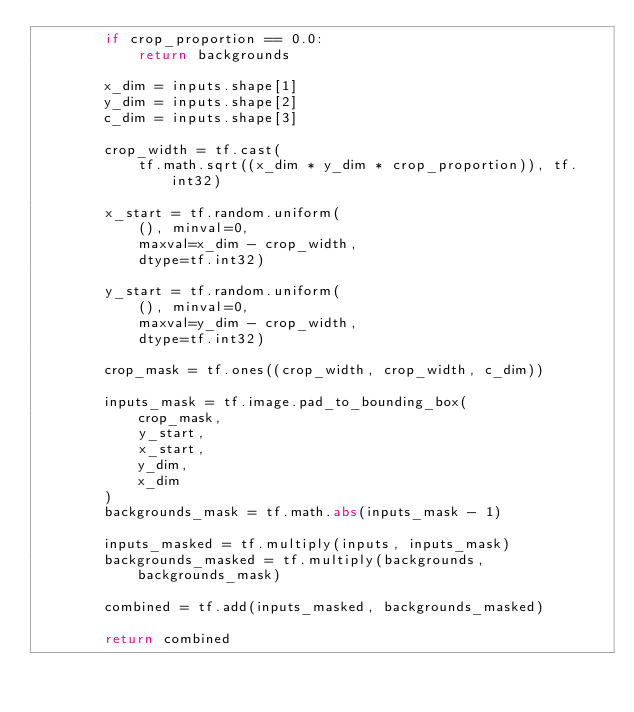<code> <loc_0><loc_0><loc_500><loc_500><_Python_>        if crop_proportion == 0.0:
            return backgrounds

        x_dim = inputs.shape[1]
        y_dim = inputs.shape[2]
        c_dim = inputs.shape[3]

        crop_width = tf.cast(
            tf.math.sqrt((x_dim * y_dim * crop_proportion)), tf.int32)

        x_start = tf.random.uniform(
            (), minval=0,
            maxval=x_dim - crop_width,
            dtype=tf.int32)

        y_start = tf.random.uniform(
            (), minval=0,
            maxval=y_dim - crop_width,
            dtype=tf.int32)

        crop_mask = tf.ones((crop_width, crop_width, c_dim))

        inputs_mask = tf.image.pad_to_bounding_box(
            crop_mask,
            y_start,
            x_start,
            y_dim,
            x_dim
        )
        backgrounds_mask = tf.math.abs(inputs_mask - 1)

        inputs_masked = tf.multiply(inputs, inputs_mask)
        backgrounds_masked = tf.multiply(backgrounds, backgrounds_mask)

        combined = tf.add(inputs_masked, backgrounds_masked)

        return combined
</code> 